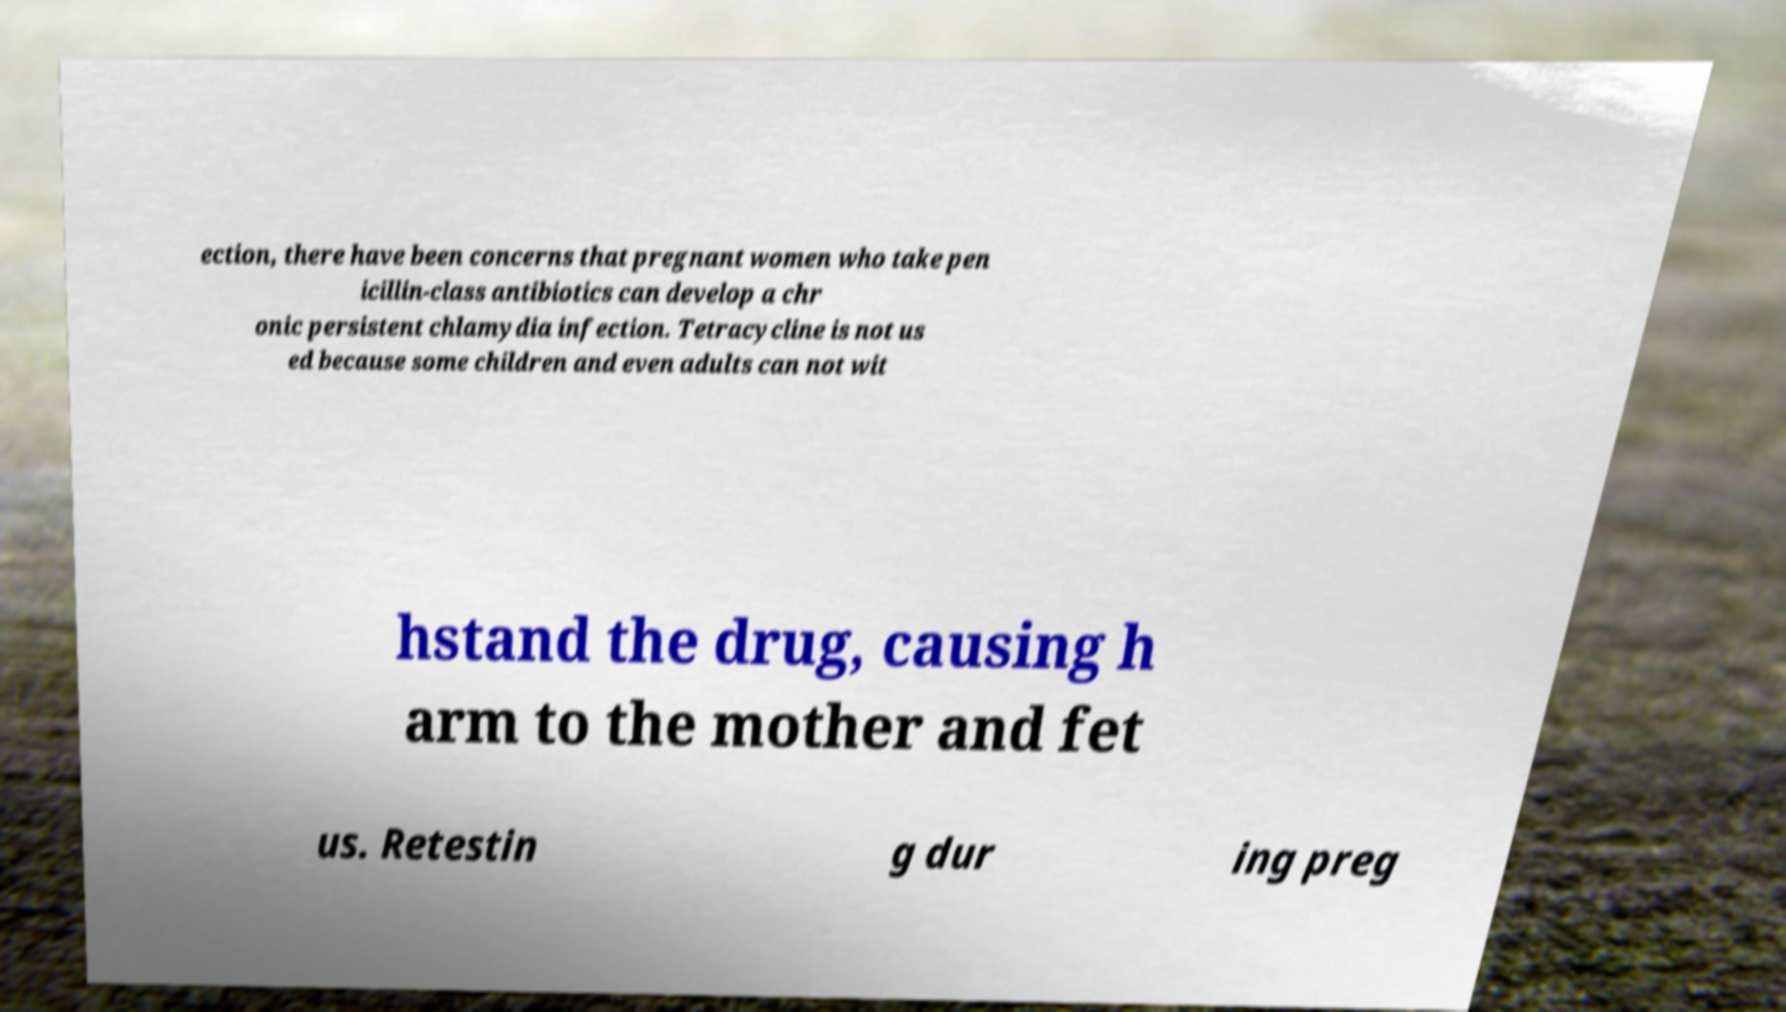Could you assist in decoding the text presented in this image and type it out clearly? ection, there have been concerns that pregnant women who take pen icillin-class antibiotics can develop a chr onic persistent chlamydia infection. Tetracycline is not us ed because some children and even adults can not wit hstand the drug, causing h arm to the mother and fet us. Retestin g dur ing preg 